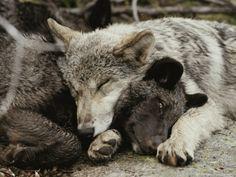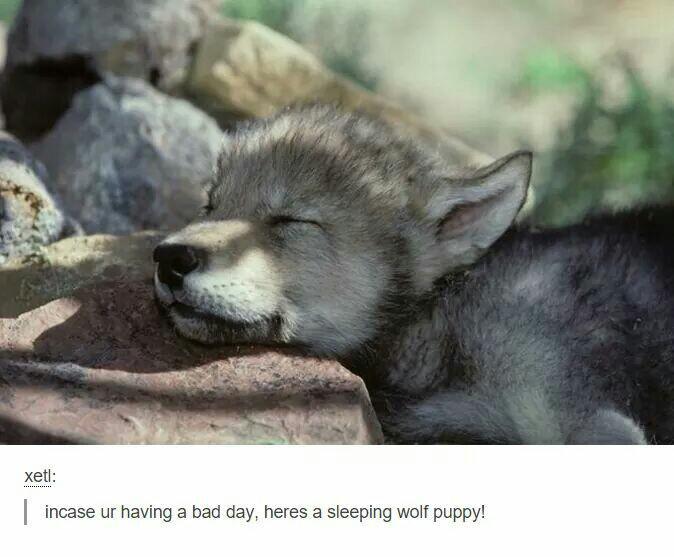The first image is the image on the left, the second image is the image on the right. For the images shown, is this caption "At least one wolf is sleeping in the snow." true? Answer yes or no. No. 